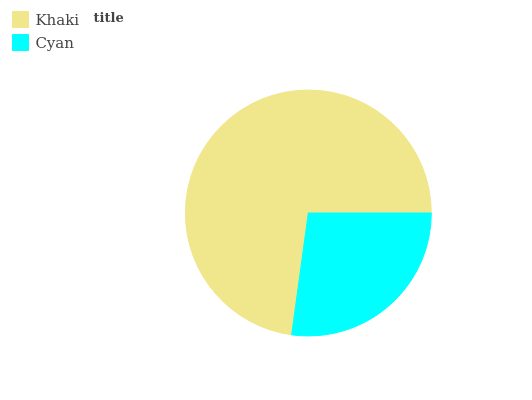Is Cyan the minimum?
Answer yes or no. Yes. Is Khaki the maximum?
Answer yes or no. Yes. Is Cyan the maximum?
Answer yes or no. No. Is Khaki greater than Cyan?
Answer yes or no. Yes. Is Cyan less than Khaki?
Answer yes or no. Yes. Is Cyan greater than Khaki?
Answer yes or no. No. Is Khaki less than Cyan?
Answer yes or no. No. Is Khaki the high median?
Answer yes or no. Yes. Is Cyan the low median?
Answer yes or no. Yes. Is Cyan the high median?
Answer yes or no. No. Is Khaki the low median?
Answer yes or no. No. 